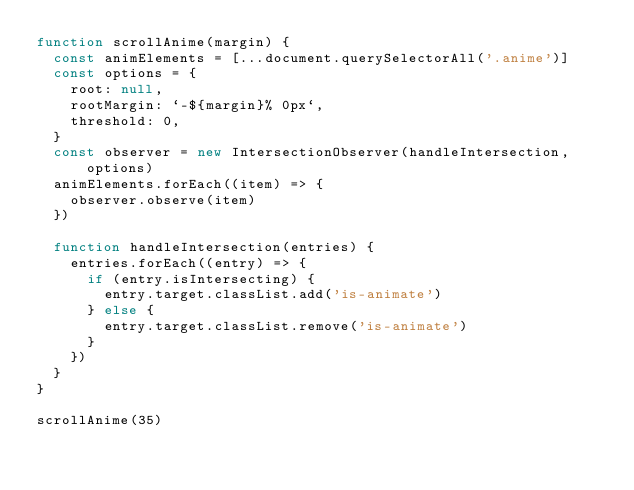Convert code to text. <code><loc_0><loc_0><loc_500><loc_500><_JavaScript_>function scrollAnime(margin) {
  const animElements = [...document.querySelectorAll('.anime')]
  const options = {
    root: null,
    rootMargin: `-${margin}% 0px`,
    threshold: 0,
  }
  const observer = new IntersectionObserver(handleIntersection, options)
  animElements.forEach((item) => {
    observer.observe(item)
  })

  function handleIntersection(entries) {
    entries.forEach((entry) => {
      if (entry.isIntersecting) {
        entry.target.classList.add('is-animate')
      } else {
        entry.target.classList.remove('is-animate')
      }
    })
  }
}

scrollAnime(35)
</code> 